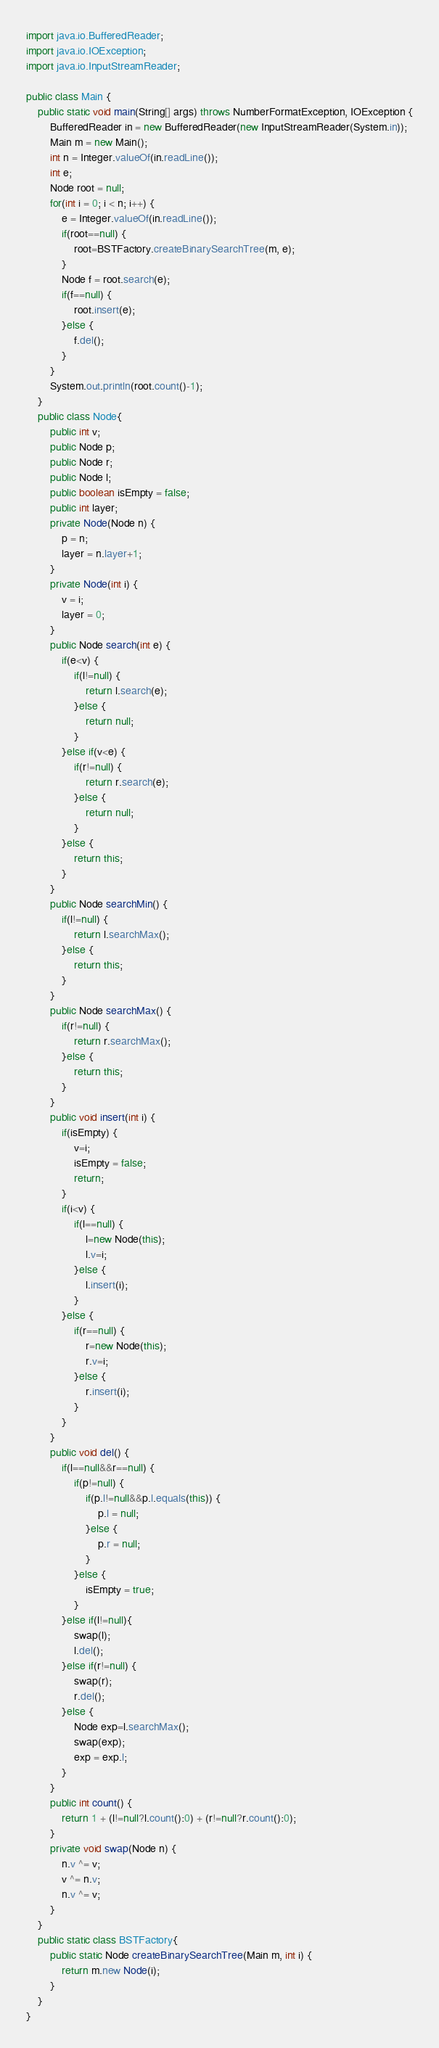<code> <loc_0><loc_0><loc_500><loc_500><_Java_>import java.io.BufferedReader;
import java.io.IOException;
import java.io.InputStreamReader;

public class Main {
	public static void main(String[] args) throws NumberFormatException, IOException {
		BufferedReader in = new BufferedReader(new InputStreamReader(System.in));
		Main m = new Main();
		int n = Integer.valueOf(in.readLine());
		int e;
		Node root = null;
		for(int i = 0; i < n; i++) {
			e = Integer.valueOf(in.readLine());
			if(root==null) {
				root=BSTFactory.createBinarySearchTree(m, e);
			}
			Node f = root.search(e);
			if(f==null) {
				root.insert(e);
			}else {
				f.del();
			}
		}
		System.out.println(root.count()-1);
	}
	public class Node{
		public int v;
		public Node p;
		public Node r;
		public Node l;
		public boolean isEmpty = false;
		public int layer;
		private Node(Node n) {
			p = n;
			layer = n.layer+1;
		}
		private Node(int i) {
			v = i;
			layer = 0;
		}
		public Node search(int e) {
			if(e<v) {
				if(l!=null) {
					return l.search(e);
				}else {
					return null;
				}
			}else if(v<e) {
				if(r!=null) {
					return r.search(e);
				}else {
					return null;
				}
			}else {
				return this;
			}
		}
		public Node searchMin() {
			if(l!=null) {
				return l.searchMax();
			}else {
				return this;
			}
		}
		public Node searchMax() {
			if(r!=null) {
				return r.searchMax();
			}else {
				return this;
			}
		}
		public void insert(int i) {
			if(isEmpty) {
				v=i;
				isEmpty = false;
				return;
			}
			if(i<v) {
				if(l==null) {
					l=new Node(this);
					l.v=i;
				}else {
					l.insert(i);
				}
			}else {
				if(r==null) {
					r=new Node(this);
					r.v=i;
				}else {
					r.insert(i);
				}
			}
		}
		public void del() {
			if(l==null&&r==null) {
				if(p!=null) {
					if(p.l!=null&&p.l.equals(this)) {
						p.l = null;
					}else {
						p.r = null;
					}
				}else {
					isEmpty = true;
				}
			}else if(l!=null){
				swap(l);
				l.del();
			}else if(r!=null) {
				swap(r);
				r.del();
			}else {
				Node exp=l.searchMax();
				swap(exp);
				exp = exp.l;
			}
		}
		public int count() {
			return 1 + (l!=null?l.count():0) + (r!=null?r.count():0);
		}
		private void swap(Node n) {
			n.v ^= v;
	        v ^= n.v;
	        n.v ^= v;
		}
	}
	public static class BSTFactory{
		public static Node createBinarySearchTree(Main m, int i) {
			return m.new Node(i);
		}
	}
}
</code> 